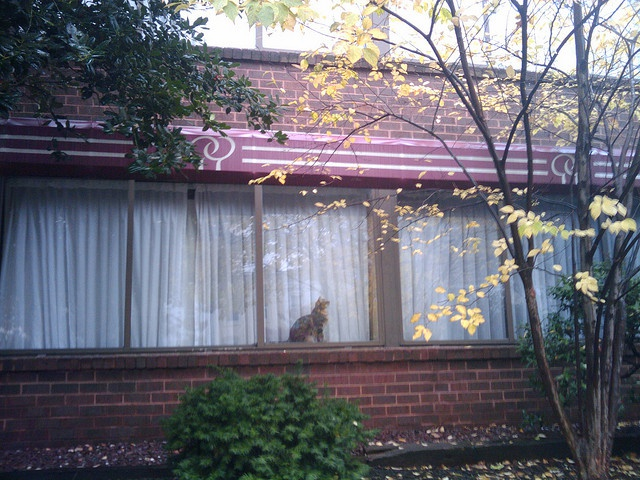Describe the objects in this image and their specific colors. I can see a cat in black, gray, and darkgray tones in this image. 